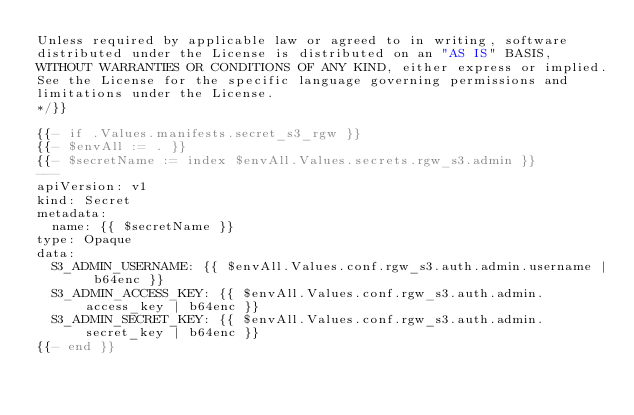Convert code to text. <code><loc_0><loc_0><loc_500><loc_500><_YAML_>Unless required by applicable law or agreed to in writing, software
distributed under the License is distributed on an "AS IS" BASIS,
WITHOUT WARRANTIES OR CONDITIONS OF ANY KIND, either express or implied.
See the License for the specific language governing permissions and
limitations under the License.
*/}}

{{- if .Values.manifests.secret_s3_rgw }}
{{- $envAll := . }}
{{- $secretName := index $envAll.Values.secrets.rgw_s3.admin }}
---
apiVersion: v1
kind: Secret
metadata:
  name: {{ $secretName }}
type: Opaque
data:
  S3_ADMIN_USERNAME: {{ $envAll.Values.conf.rgw_s3.auth.admin.username | b64enc }}
  S3_ADMIN_ACCESS_KEY: {{ $envAll.Values.conf.rgw_s3.auth.admin.access_key | b64enc }}
  S3_ADMIN_SECRET_KEY: {{ $envAll.Values.conf.rgw_s3.auth.admin.secret_key | b64enc }}
{{- end }}
</code> 